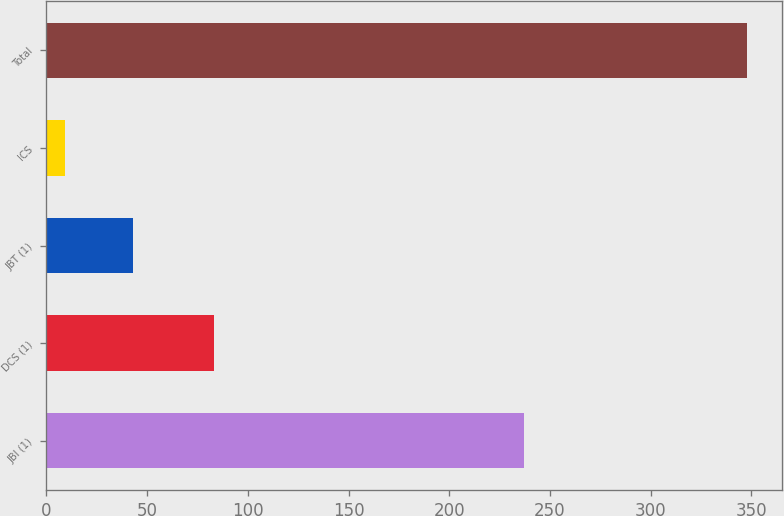Convert chart to OTSL. <chart><loc_0><loc_0><loc_500><loc_500><bar_chart><fcel>JBI (1)<fcel>DCS (1)<fcel>JBT (1)<fcel>ICS<fcel>Total<nl><fcel>237<fcel>83<fcel>42.9<fcel>9<fcel>348<nl></chart> 